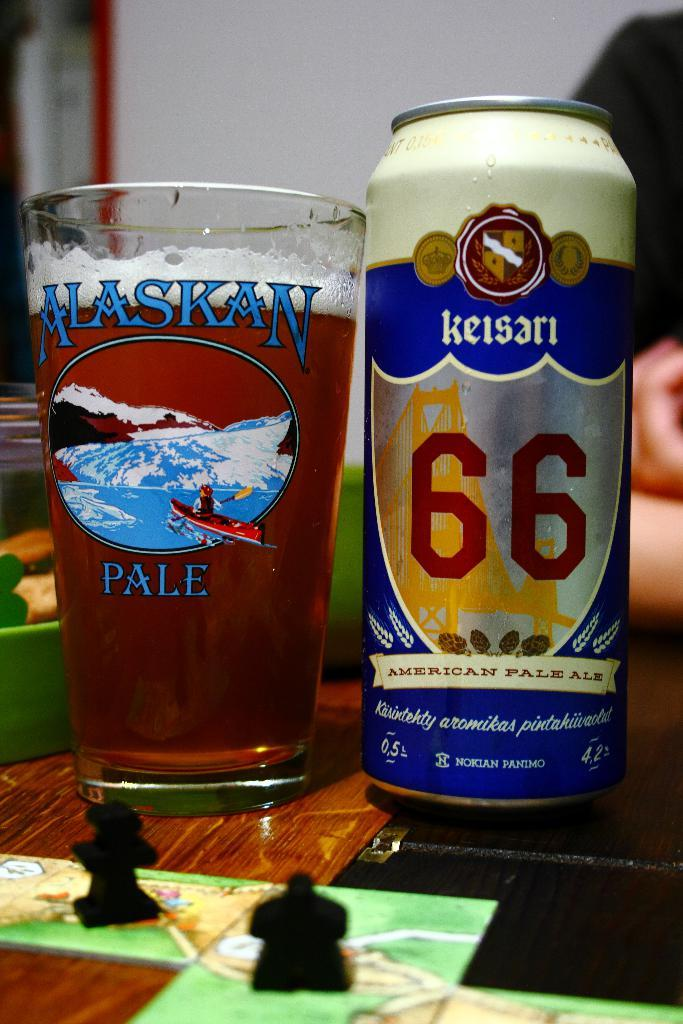<image>
Share a concise interpretation of the image provided. The Alaskan Pale glass is full of beer and is next to a can of Keisari ale. 